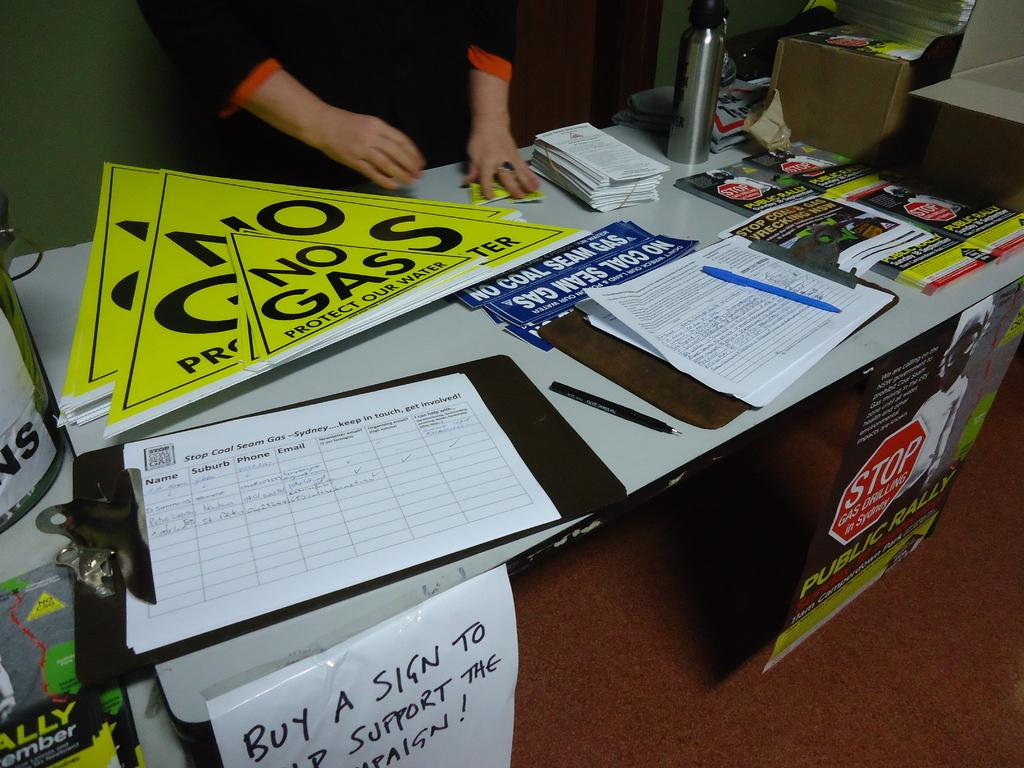Provide a one-sentence caption for the provided image. A table is set up to sell signs in support of a No Gas protest. 